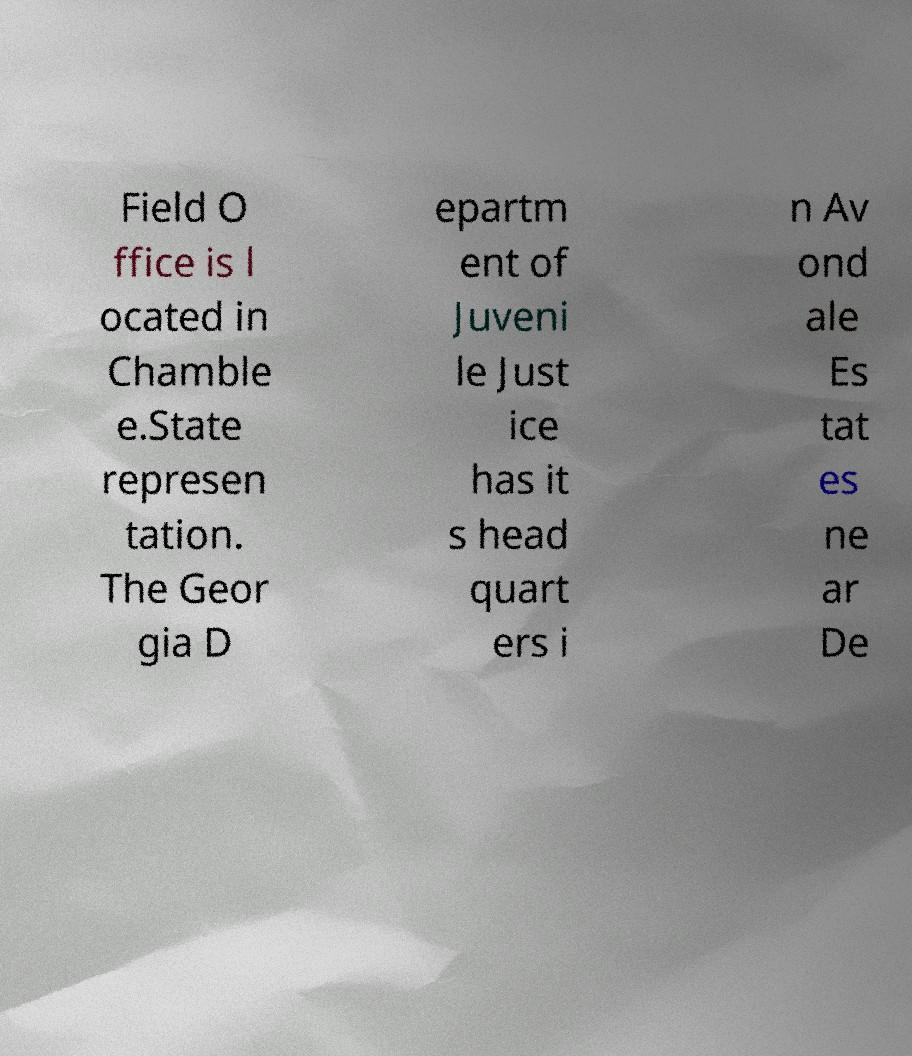Please identify and transcribe the text found in this image. Field O ffice is l ocated in Chamble e.State represen tation. The Geor gia D epartm ent of Juveni le Just ice has it s head quart ers i n Av ond ale Es tat es ne ar De 